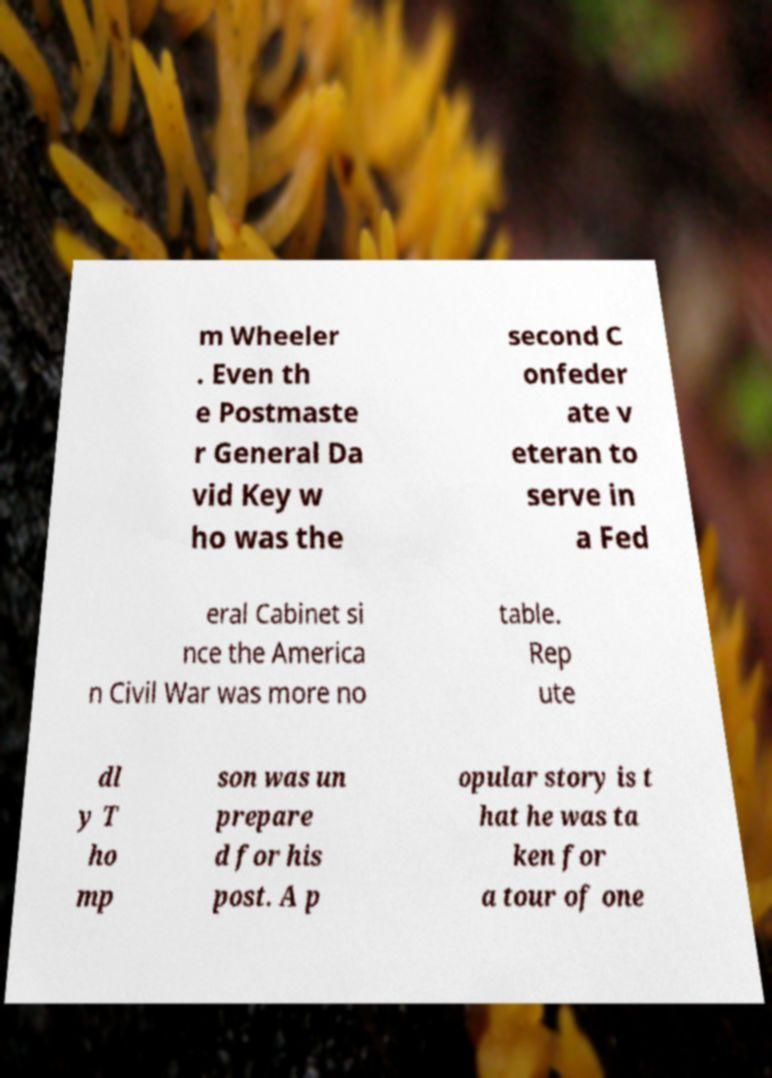Please identify and transcribe the text found in this image. m Wheeler . Even th e Postmaste r General Da vid Key w ho was the second C onfeder ate v eteran to serve in a Fed eral Cabinet si nce the America n Civil War was more no table. Rep ute dl y T ho mp son was un prepare d for his post. A p opular story is t hat he was ta ken for a tour of one 